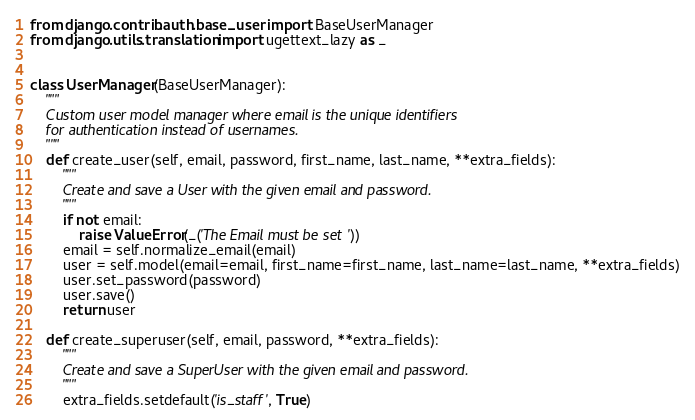<code> <loc_0><loc_0><loc_500><loc_500><_Python_>from django.contrib.auth.base_user import BaseUserManager
from django.utils.translation import ugettext_lazy as _


class UserManager(BaseUserManager):
    """
    Custom user model manager where email is the unique identifiers
    for authentication instead of usernames.
    """
    def create_user(self, email, password, first_name, last_name, **extra_fields):
        """
        Create and save a User with the given email and password.
        """
        if not email:
            raise ValueError(_('The Email must be set'))
        email = self.normalize_email(email)
        user = self.model(email=email, first_name=first_name, last_name=last_name, **extra_fields)
        user.set_password(password)
        user.save()
        return user

    def create_superuser(self, email, password, **extra_fields):
        """
        Create and save a SuperUser with the given email and password.
        """
        extra_fields.setdefault('is_staff', True)</code> 